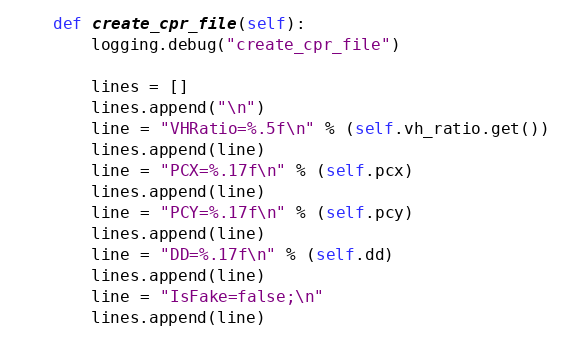Convert code to text. <code><loc_0><loc_0><loc_500><loc_500><_Python_>
    def create_cpr_file(self):
        logging.debug("create_cpr_file")

        lines = []
        lines.append("\n")
        line = "VHRatio=%.5f\n" % (self.vh_ratio.get())
        lines.append(line)
        line = "PCX=%.17f\n" % (self.pcx)
        lines.append(line)
        line = "PCY=%.17f\n" % (self.pcy)
        lines.append(line)
        line = "DD=%.17f\n" % (self.dd)
        lines.append(line)
        line = "IsFake=false;\n"
        lines.append(line)</code> 